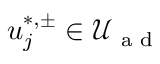Convert formula to latex. <formula><loc_0><loc_0><loc_500><loc_500>u _ { j } ^ { * , \pm } \in \mathcal { U } _ { a d }</formula> 